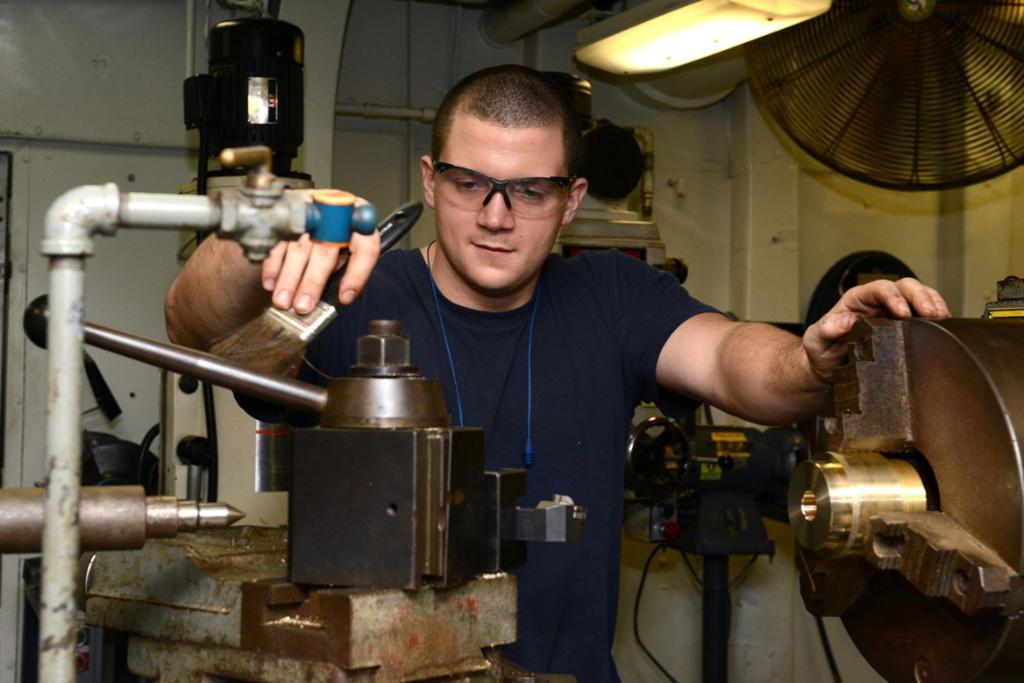Can you describe this image briefly? In the middle of this image, there is a person in violet color T-shirt, holding a brush with a hand, holding a wheel of a machine with the other hand. On the left side, there is a needle and a pipe which is having a valve. In the background, there is a fan, a white wall and other objects. 